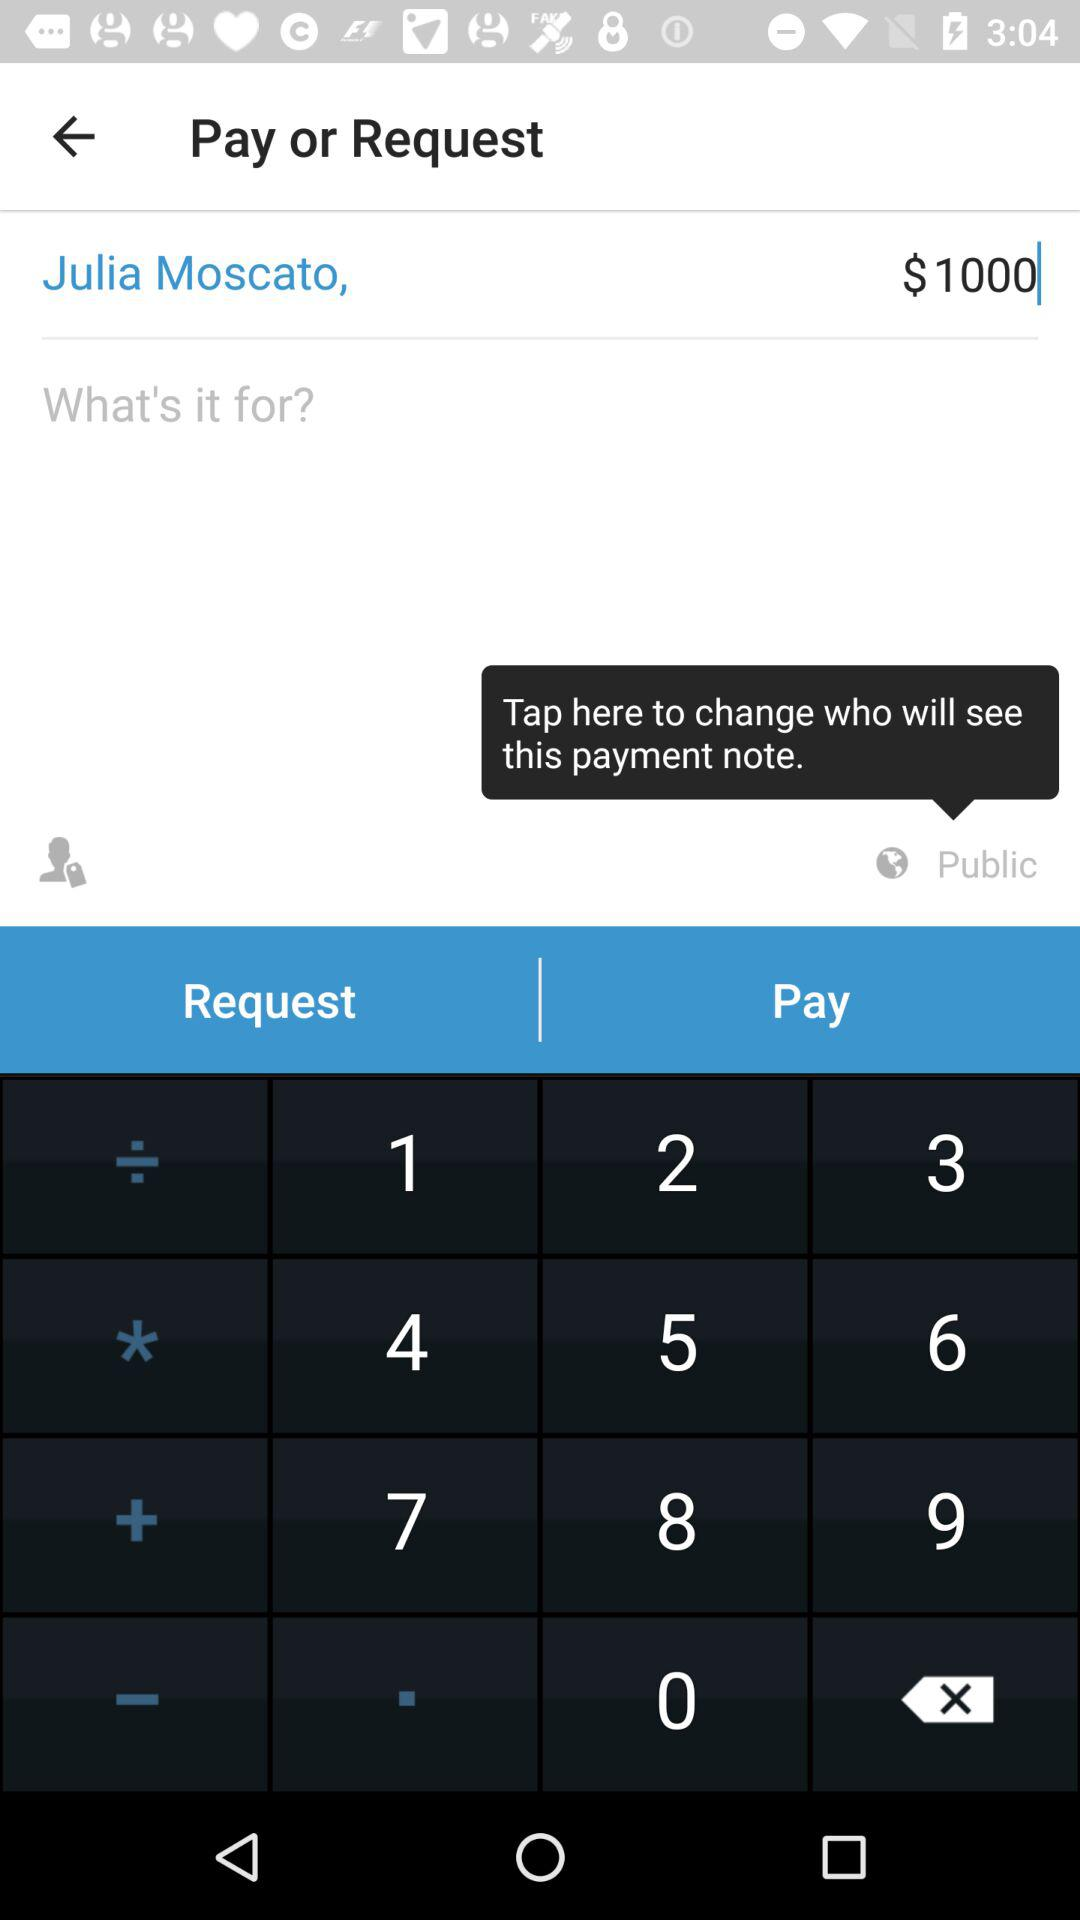What is the user name? The user name is Julia Moscato. 